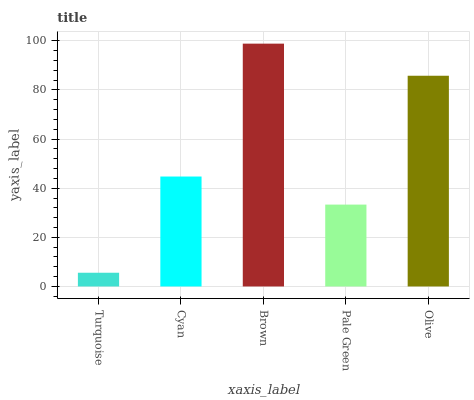Is Turquoise the minimum?
Answer yes or no. Yes. Is Brown the maximum?
Answer yes or no. Yes. Is Cyan the minimum?
Answer yes or no. No. Is Cyan the maximum?
Answer yes or no. No. Is Cyan greater than Turquoise?
Answer yes or no. Yes. Is Turquoise less than Cyan?
Answer yes or no. Yes. Is Turquoise greater than Cyan?
Answer yes or no. No. Is Cyan less than Turquoise?
Answer yes or no. No. Is Cyan the high median?
Answer yes or no. Yes. Is Cyan the low median?
Answer yes or no. Yes. Is Olive the high median?
Answer yes or no. No. Is Turquoise the low median?
Answer yes or no. No. 